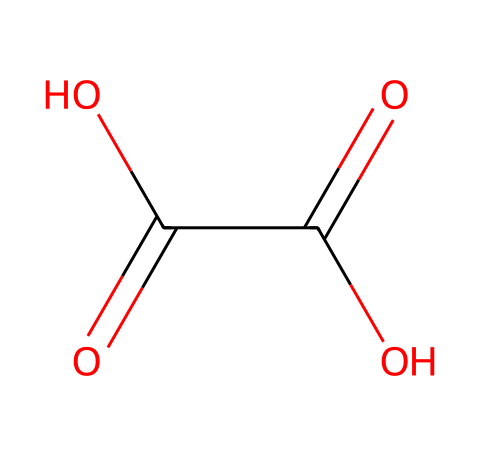How many carbon atoms are in the structure of oxalic acid? The SMILES representation "O=C(O)C(=O)O" indicates there are two carbon atoms, as "C" appears twice in the depiction.
Answer: two What is the total number of oxygen atoms present in oxalic acid? Counting the "O" in the SMILES representation, we see three occurrences of the oxygen letter ("O"), which indicates there are three oxygen atoms in the structure.
Answer: three What functional groups are present in oxalic acid? The chemical structure shows two carboxylic acid groups (-COOH), characterized by the presence of carbon atoms double-bonded to oxygen atoms and single-bonded to hydroxyl groups.
Answer: carboxylic acid How does the arrangement of atoms influence the acidity of oxalic acid? Oxalic acid has two carboxylic acid groups, each capable of donating hydrogen ions (protons), which explains its strong acidic nature due to increased proton availability.
Answer: strong acidity What is the pKa value of oxalic acid? The first pKa of oxalic acid is approximately 1.5. This indicates its strong tendency to dissociate in solution, pushing the equilibrium toward the addition of free protons.
Answer: 1.5 How many hydrogen atoms are in the molecular structure of oxalic acid? The two -COOH groups provide a total of 2 hydrogen atoms, as each carboxylic acid group contains one hydrogen, resulting in a total of two.
Answer: two 